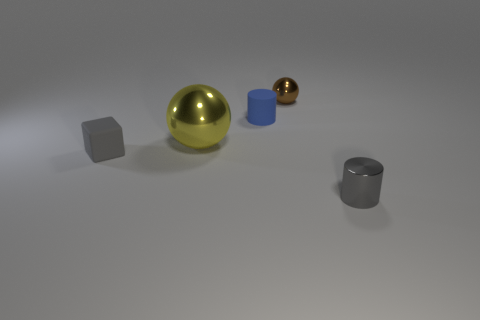Add 3 small gray matte objects. How many objects exist? 8 Subtract all spheres. How many objects are left? 3 Subtract 0 green cylinders. How many objects are left? 5 Subtract all tiny shiny cylinders. Subtract all tiny rubber cylinders. How many objects are left? 3 Add 3 tiny gray metallic cylinders. How many tiny gray metallic cylinders are left? 4 Add 4 metallic objects. How many metallic objects exist? 7 